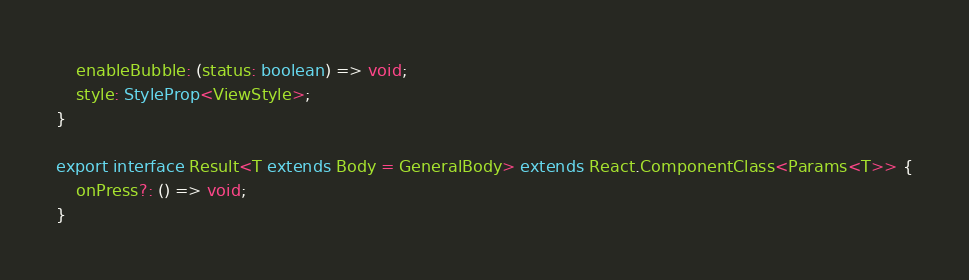<code> <loc_0><loc_0><loc_500><loc_500><_TypeScript_>    enableBubble: (status: boolean) => void;
    style: StyleProp<ViewStyle>;
}

export interface Result<T extends Body = GeneralBody> extends React.ComponentClass<Params<T>> {
    onPress?: () => void;
}</code> 